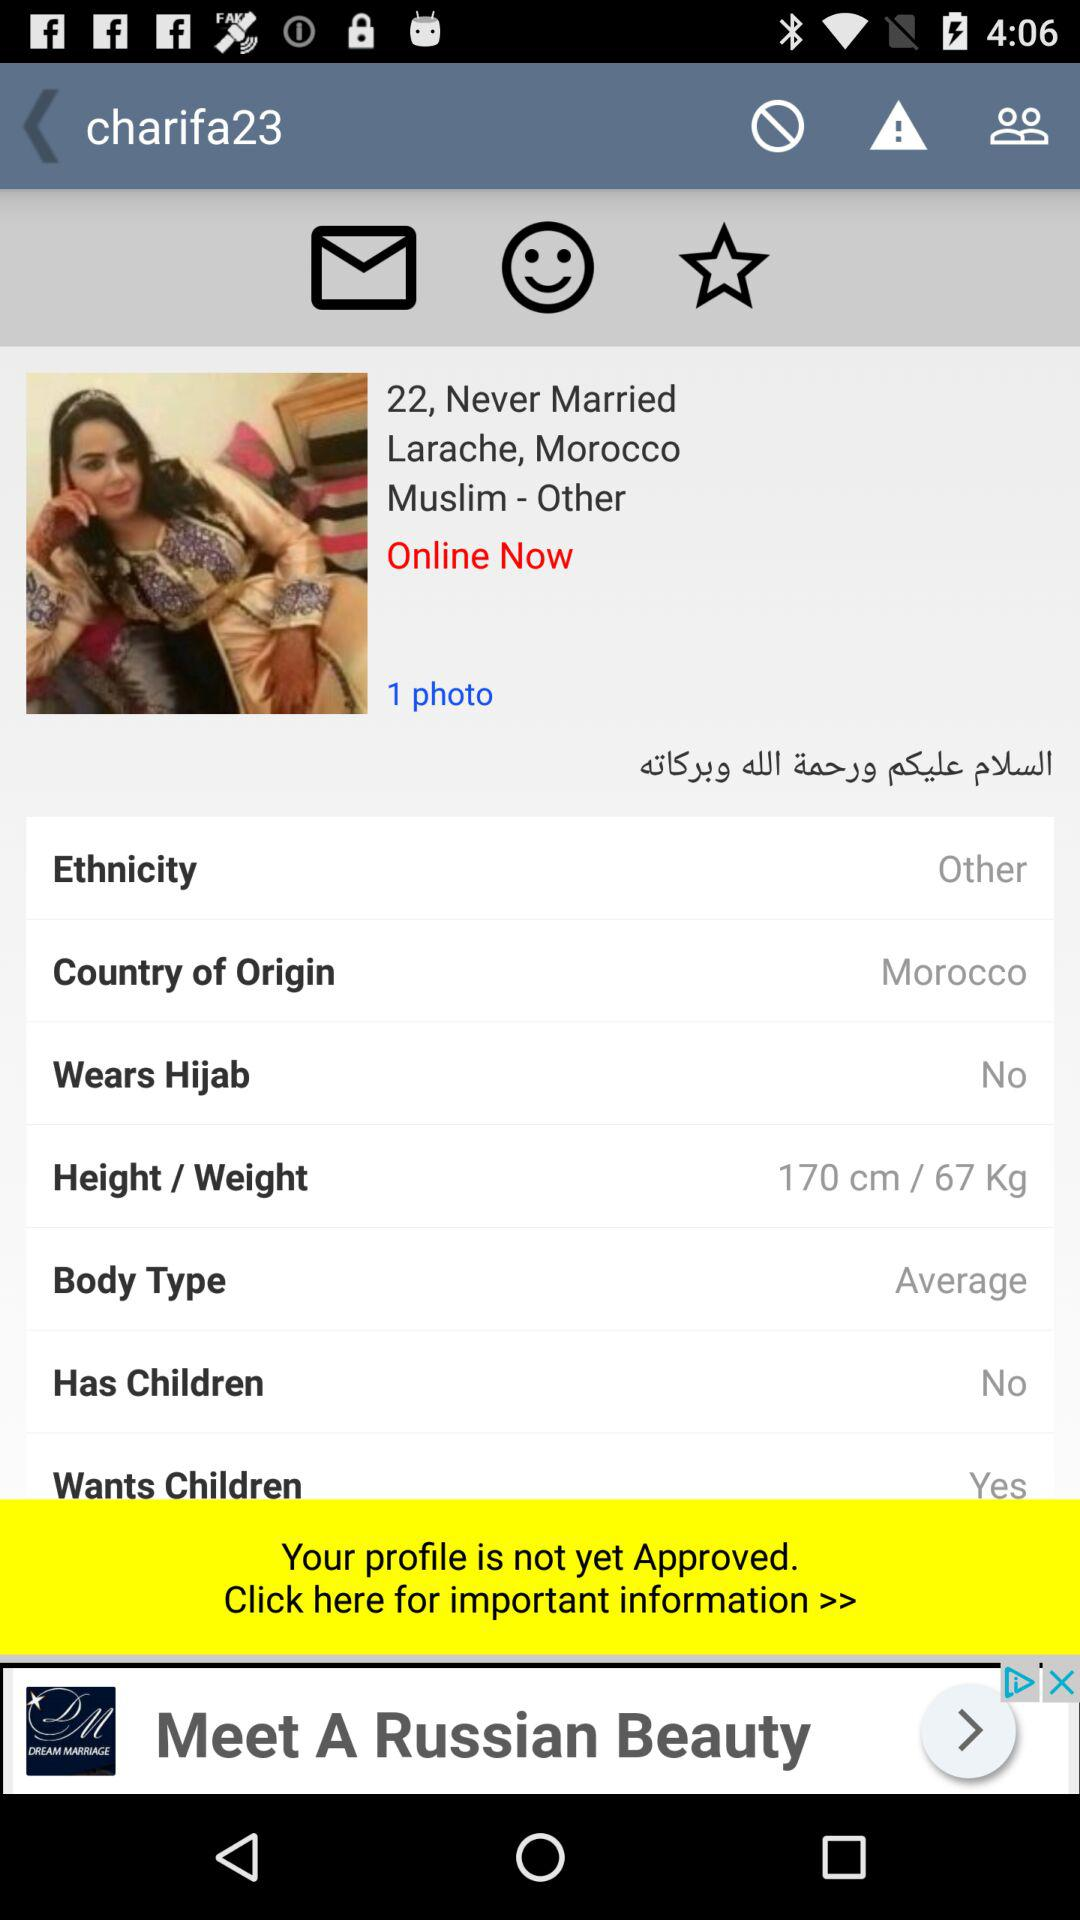What is the number of photos? There is one photo. 